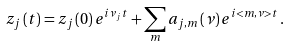<formula> <loc_0><loc_0><loc_500><loc_500>z _ { j } \left ( t \right ) = z _ { j } \left ( 0 \right ) e ^ { i \nu _ { j } t } + \sum _ { m } a _ { j , m } \left ( \nu \right ) e ^ { i < m , \nu > t } \, .</formula> 